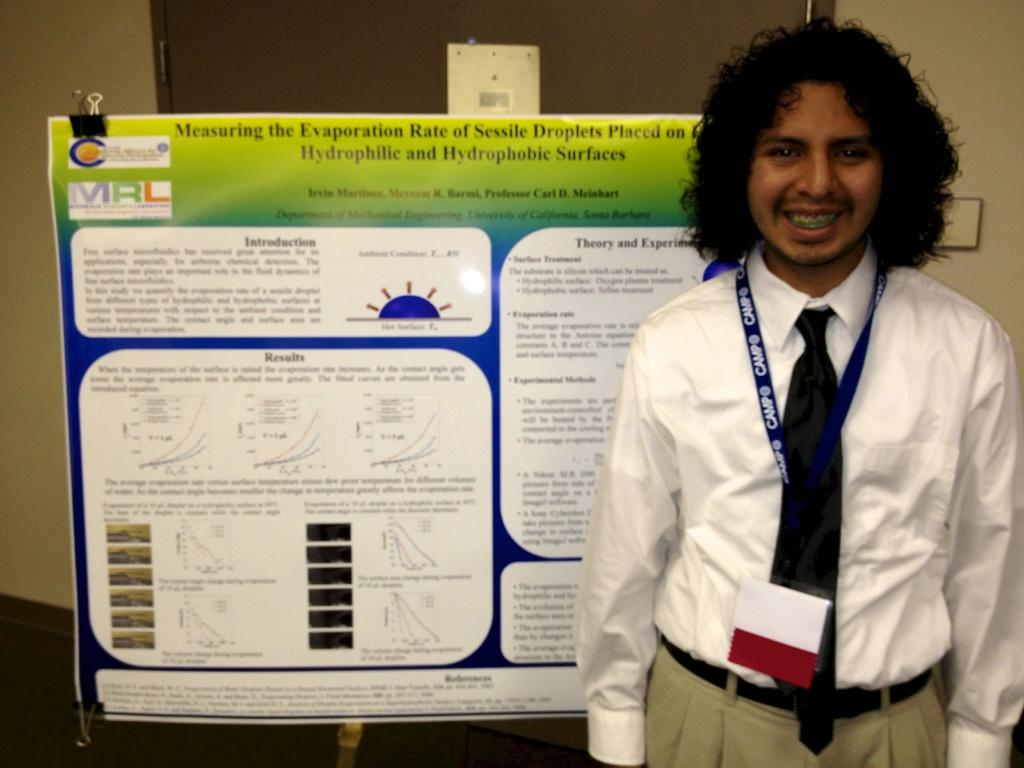Who is present in the image? There is a man in the image. What is the man doing in the image? The man is standing and smiling. What is located behind the man in the image? There is a banner behind the man. What is visible behind the banner in the image? There is a wall visible in the image behind the banner. What type of pear is the man holding in the image? There is no pear present in the image; the man is not holding anything. 